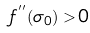<formula> <loc_0><loc_0><loc_500><loc_500>f ^ { ^ { \prime \prime } } ( \sigma _ { 0 } ) > 0</formula> 